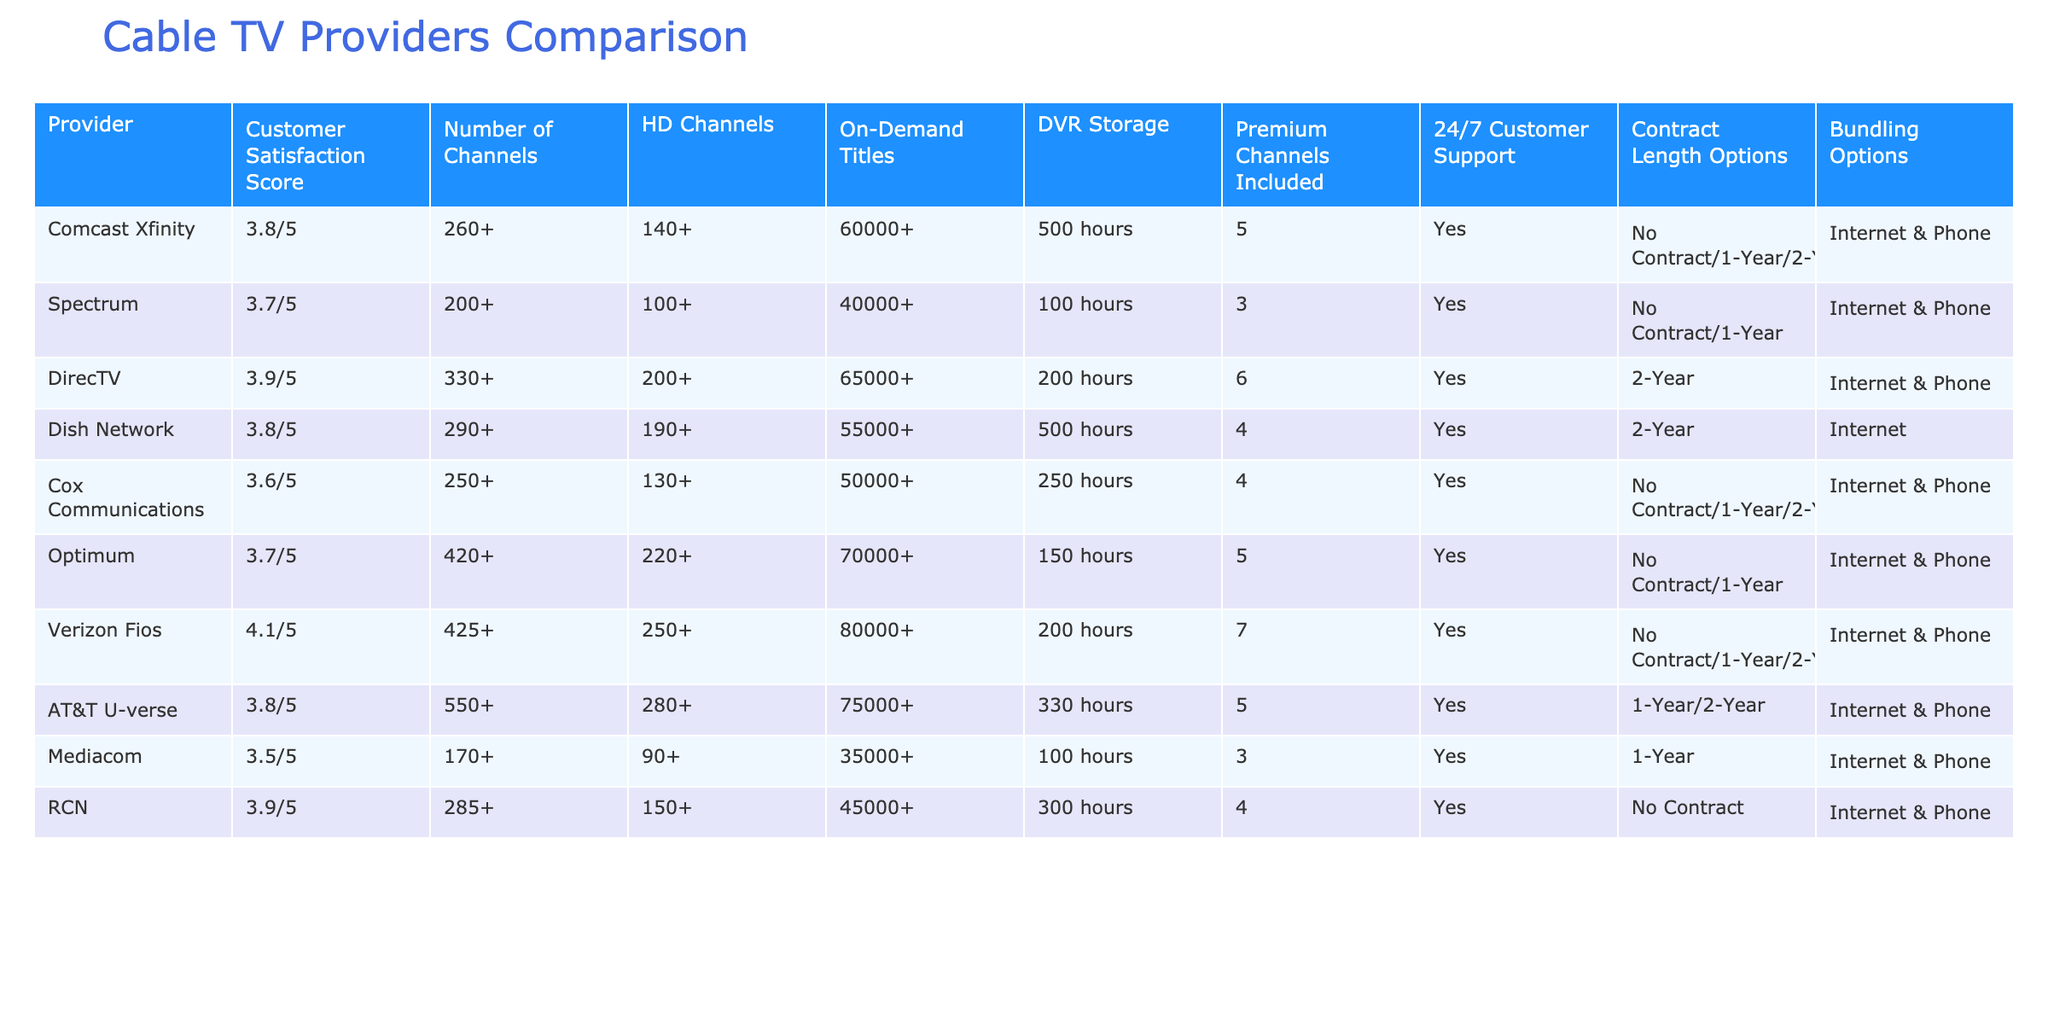What is the customer satisfaction score of Verizon Fios? The table shows that Verizon Fios has a customer satisfaction score of 4.1 out of 5.
Answer: 4.1/5 Which provider has the highest number of HD channels? Upon reviewing the table, Verizon Fios also has the highest number of HD channels at 250+, compared to other providers.
Answer: 250+ Is there any provider that offers no contract options? Both Comcast Xfinity and Cox Communications provide no contract options as listed in the "Contract Length Options" column.
Answer: Yes Which provider has the most on-demand titles? By checking the table, Optimum has the most on-demand titles with a total of 70,000+.
Answer: 70,000+ What is the average DVR storage among the providers listed? To find the average DVR storage, we sum the DVR storage values (500, 100, 200, 500, 250, 150, 200, 330, 100, 300), which is 2,430 hours. There are 10 providers, so we divide 2,430 by 10 to get an average of 243 hours.
Answer: 243 hours Does DirecTV offer 24/7 customer support? The table indicates that DirecTV does provide 24/7 customer support, as it is marked "Yes" in the respective column.
Answer: Yes Which provider offers the smallest number of channels? From the table, Mediacom offers the smallest number of channels, which is 170+.
Answer: 170+ If I want the highest number of premium channels included, which provider should I choose? By analyzing the table, Verizon Fios offers the highest number with 7 premium channels included, making it the best choice for this criterion.
Answer: 7 What is the contract length option for RCN? RCN has the option for no contract as stated under the "Contract Length Options" column, which is beneficial for customers seeking flexibility.
Answer: No Contract 